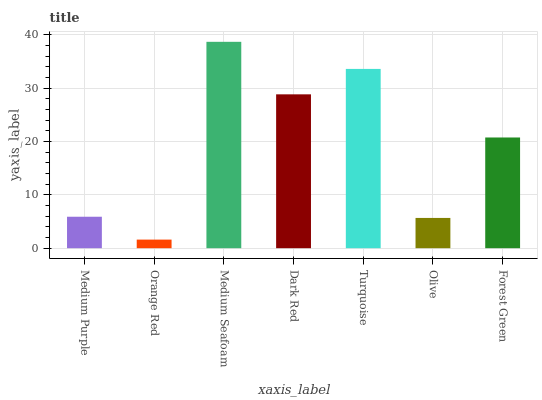Is Orange Red the minimum?
Answer yes or no. Yes. Is Medium Seafoam the maximum?
Answer yes or no. Yes. Is Medium Seafoam the minimum?
Answer yes or no. No. Is Orange Red the maximum?
Answer yes or no. No. Is Medium Seafoam greater than Orange Red?
Answer yes or no. Yes. Is Orange Red less than Medium Seafoam?
Answer yes or no. Yes. Is Orange Red greater than Medium Seafoam?
Answer yes or no. No. Is Medium Seafoam less than Orange Red?
Answer yes or no. No. Is Forest Green the high median?
Answer yes or no. Yes. Is Forest Green the low median?
Answer yes or no. Yes. Is Turquoise the high median?
Answer yes or no. No. Is Turquoise the low median?
Answer yes or no. No. 